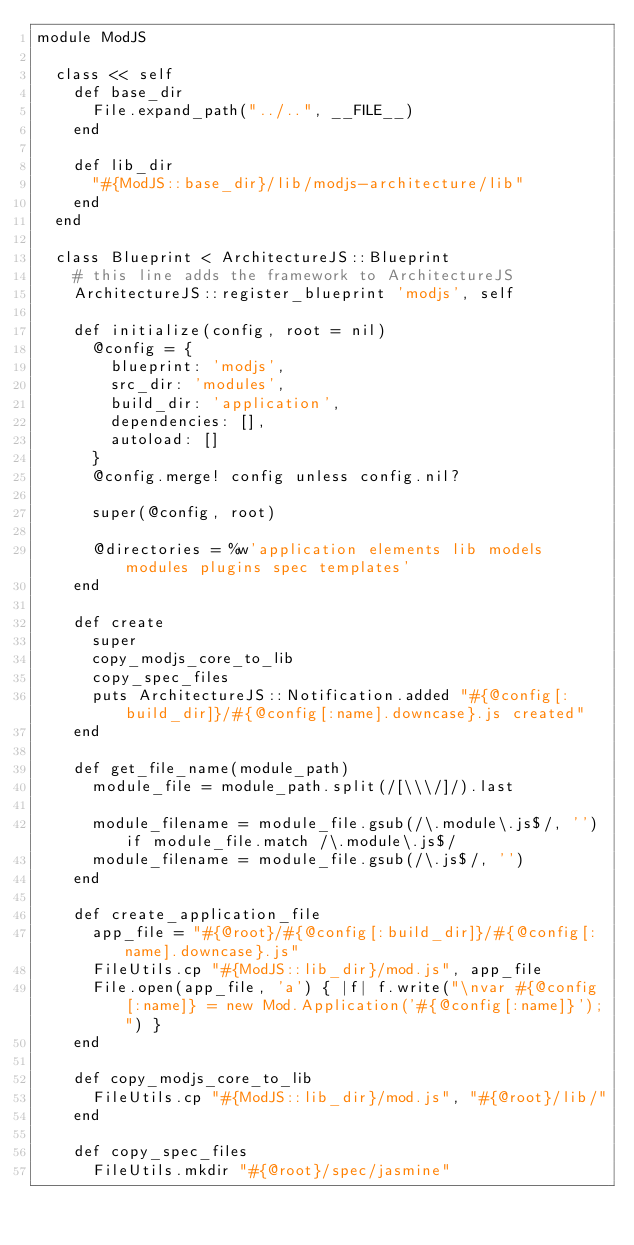Convert code to text. <code><loc_0><loc_0><loc_500><loc_500><_Ruby_>module ModJS

  class << self
    def base_dir
      File.expand_path("../..", __FILE__)
    end

    def lib_dir
      "#{ModJS::base_dir}/lib/modjs-architecture/lib"
    end
  end

  class Blueprint < ArchitectureJS::Blueprint
    # this line adds the framework to ArchitectureJS
    ArchitectureJS::register_blueprint 'modjs', self

    def initialize(config, root = nil)
      @config = {
        blueprint: 'modjs',
        src_dir: 'modules',
        build_dir: 'application',
        dependencies: [],
        autoload: []
      }
      @config.merge! config unless config.nil?

      super(@config, root)

      @directories = %w'application elements lib models modules plugins spec templates'
    end

    def create
      super
      copy_modjs_core_to_lib
      copy_spec_files
      puts ArchitectureJS::Notification.added "#{@config[:build_dir]}/#{@config[:name].downcase}.js created"
    end

    def get_file_name(module_path)
      module_file = module_path.split(/[\\\/]/).last

      module_filename = module_file.gsub(/\.module\.js$/, '') if module_file.match /\.module\.js$/
      module_filename = module_file.gsub(/\.js$/, '')
    end

    def create_application_file
      app_file = "#{@root}/#{@config[:build_dir]}/#{@config[:name].downcase}.js"
      FileUtils.cp "#{ModJS::lib_dir}/mod.js", app_file
      File.open(app_file, 'a') { |f| f.write("\nvar #{@config[:name]} = new Mod.Application('#{@config[:name]}');") }
    end

    def copy_modjs_core_to_lib
      FileUtils.cp "#{ModJS::lib_dir}/mod.js", "#{@root}/lib/"
    end

    def copy_spec_files
      FileUtils.mkdir "#{@root}/spec/jasmine"</code> 